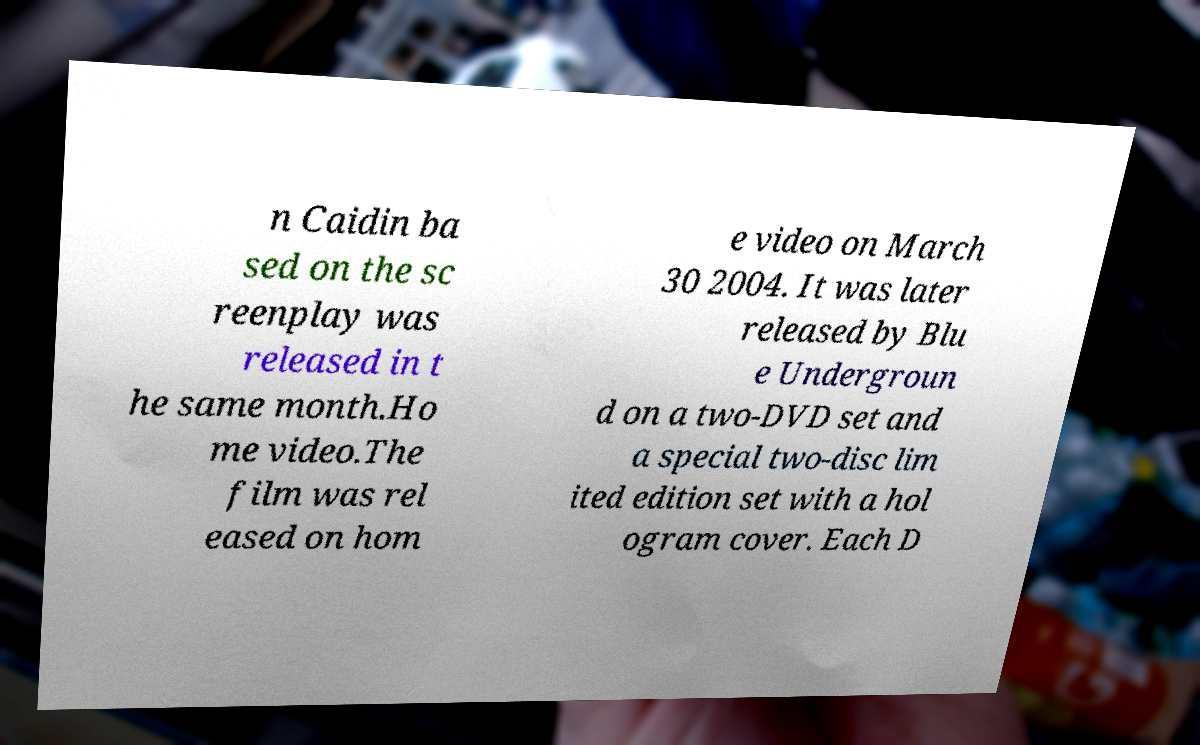Could you extract and type out the text from this image? n Caidin ba sed on the sc reenplay was released in t he same month.Ho me video.The film was rel eased on hom e video on March 30 2004. It was later released by Blu e Undergroun d on a two-DVD set and a special two-disc lim ited edition set with a hol ogram cover. Each D 